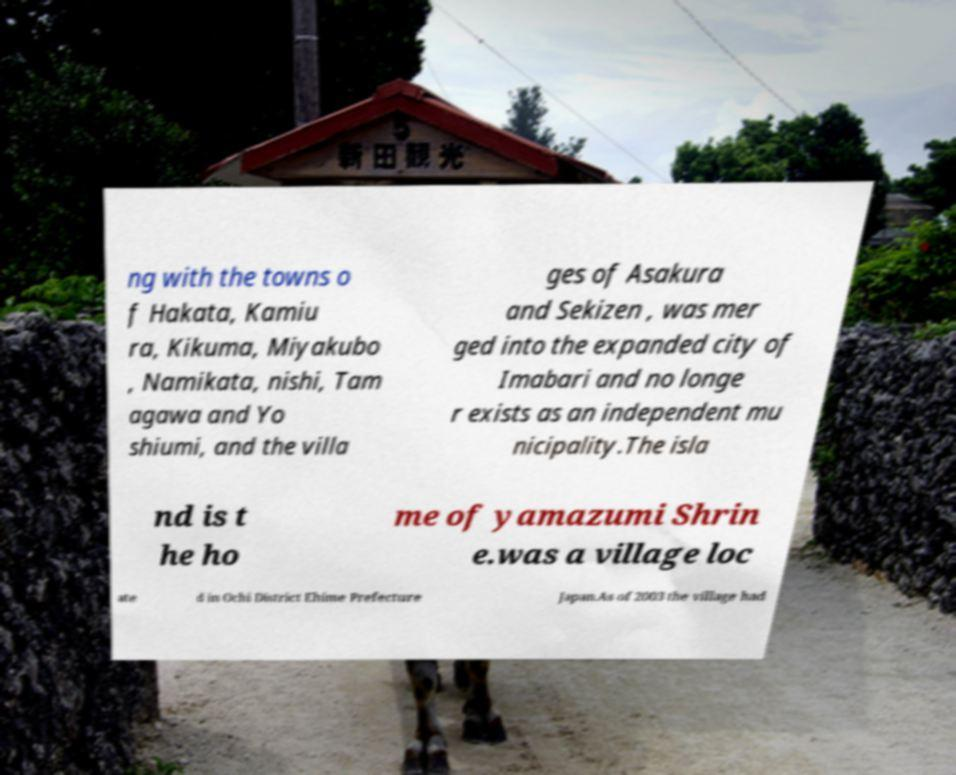What messages or text are displayed in this image? I need them in a readable, typed format. ng with the towns o f Hakata, Kamiu ra, Kikuma, Miyakubo , Namikata, nishi, Tam agawa and Yo shiumi, and the villa ges of Asakura and Sekizen , was mer ged into the expanded city of Imabari and no longe r exists as an independent mu nicipality.The isla nd is t he ho me of yamazumi Shrin e.was a village loc ate d in Ochi District Ehime Prefecture Japan.As of 2003 the village had 